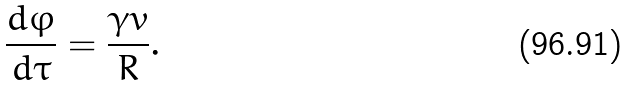Convert formula to latex. <formula><loc_0><loc_0><loc_500><loc_500>\frac { d \varphi } { d \tau } = \frac { \gamma v } { R } .</formula> 